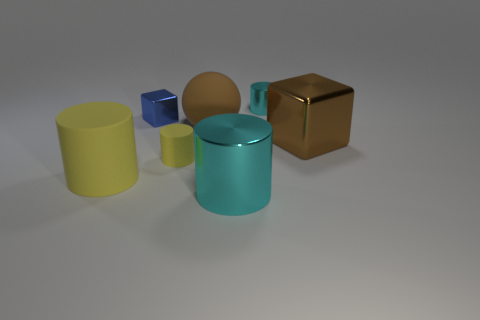Add 2 small brown shiny blocks. How many objects exist? 9 Subtract all cylinders. How many objects are left? 3 Subtract all yellow objects. Subtract all big brown shiny objects. How many objects are left? 4 Add 1 big rubber spheres. How many big rubber spheres are left? 2 Add 2 tiny blue shiny cylinders. How many tiny blue shiny cylinders exist? 2 Subtract 0 cyan spheres. How many objects are left? 7 